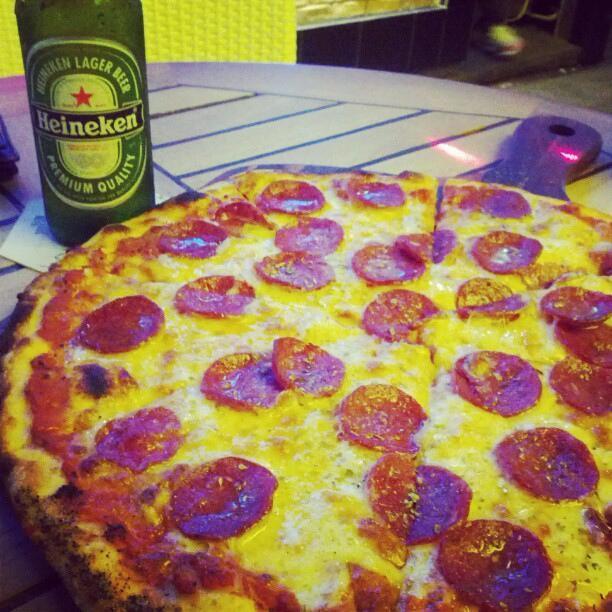How many donuts can be seen?
Give a very brief answer. 7. 